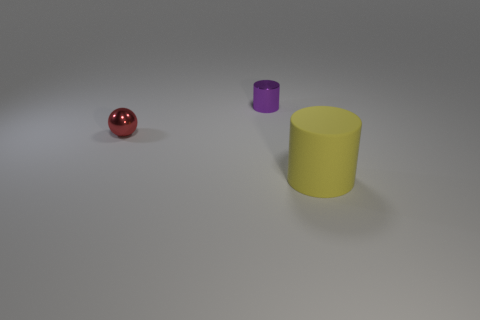Subtract all purple cylinders. Subtract all gray spheres. How many cylinders are left? 1 Add 2 small red matte balls. How many objects exist? 5 Subtract all balls. How many objects are left? 2 Subtract 0 gray blocks. How many objects are left? 3 Subtract all blue cylinders. Subtract all tiny red objects. How many objects are left? 2 Add 1 cylinders. How many cylinders are left? 3 Add 2 tiny purple cylinders. How many tiny purple cylinders exist? 3 